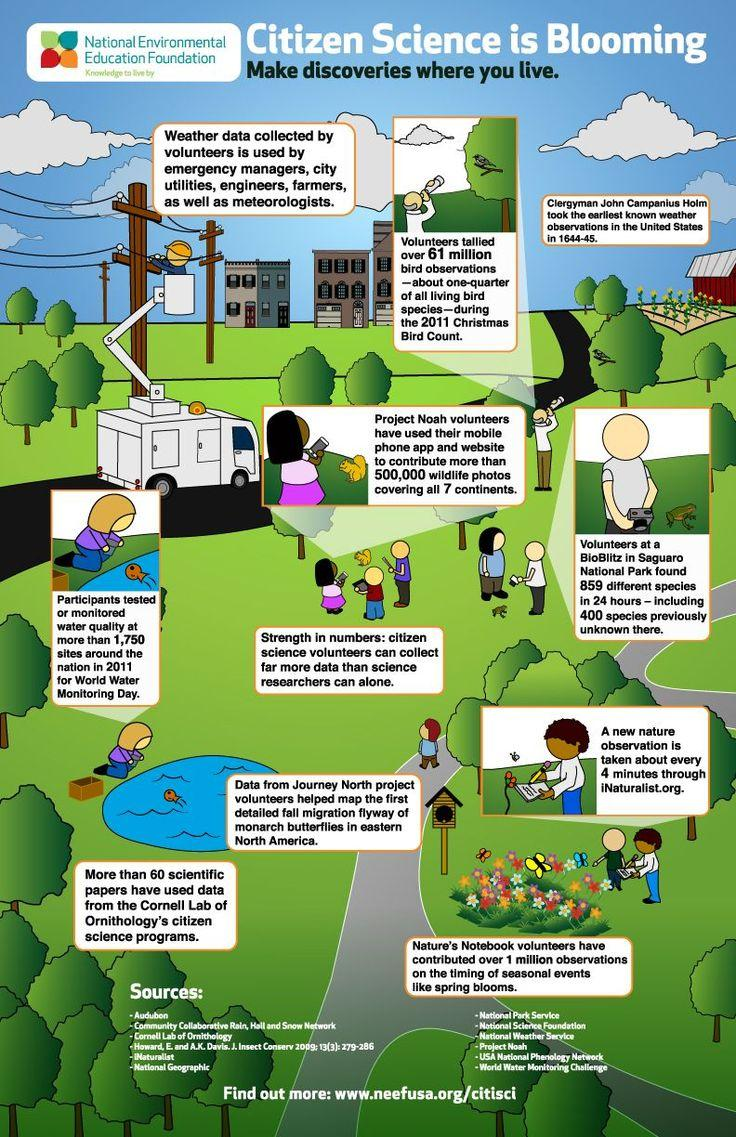List a handful of essential elements in this visual. The infographic contains two fish. This infographic contains four buildings. 